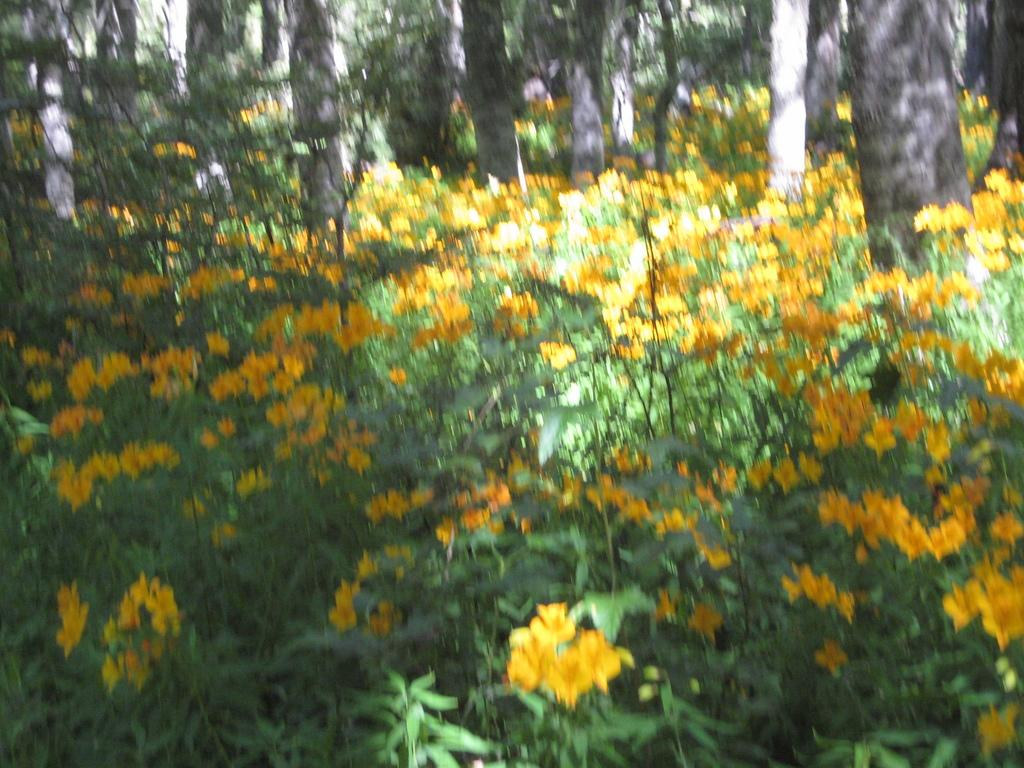What type of natural structures are present in the image? There are tree trunks in the image. What type of vegetation can be seen in the image? There are trees in the image. What color are the flowers visible in the image? There are yellow color flowers in the image. How many pages are visible in the image? There are no pages present in the image. What type of account is being referred to in the image? There is no account mentioned or visible in the image. 